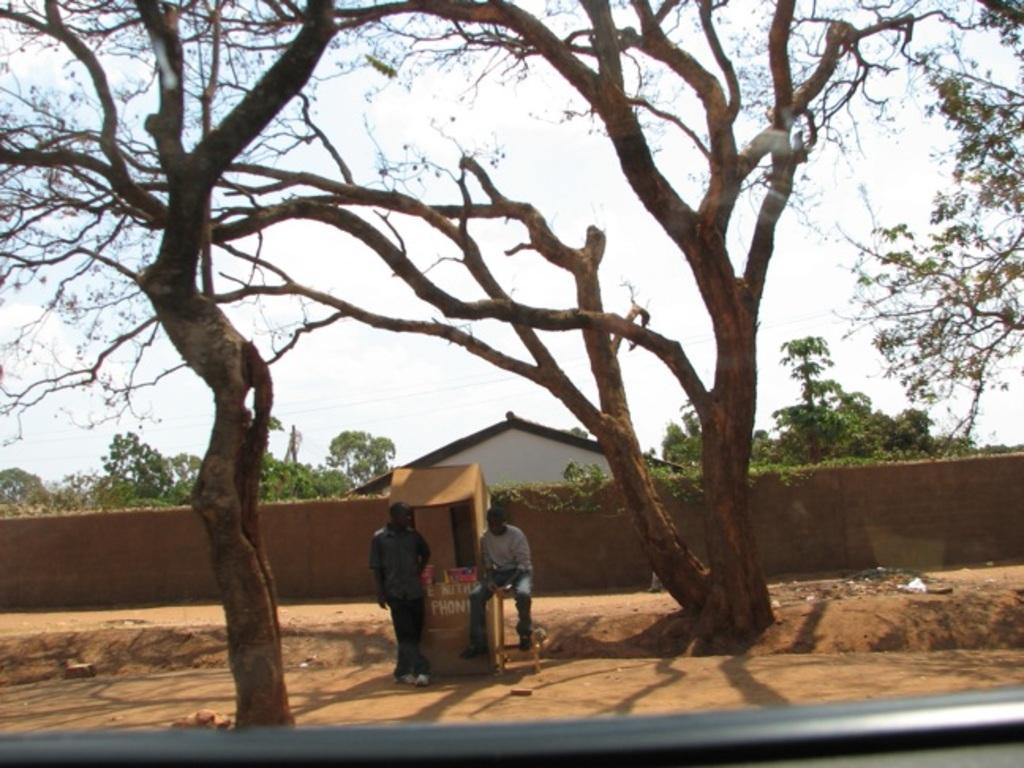What is located in the center of the image? There are trees in the center of the image. What type of structure can be seen in the image? There is a wall and a building in the image. How many people are present in the image? There are two people standing in the image. What type of copper material can be seen in the image? There is no copper material present in the image. How many bees are visible in the image? There are no bees visible in the image. 